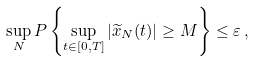<formula> <loc_0><loc_0><loc_500><loc_500>\sup _ { N } P \left \{ \sup _ { t \in [ 0 , T ] } | \widetilde { x } _ { N } ( t ) | \geq M \right \} \leq \varepsilon \, ,</formula> 